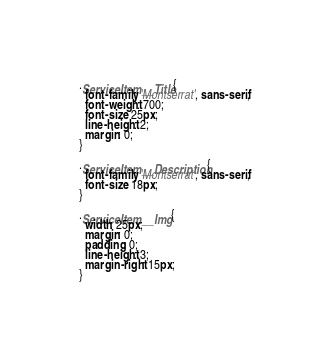Convert code to text. <code><loc_0><loc_0><loc_500><loc_500><_CSS_>.ServiceItem__Title {
  font-family: 'Montserrat', sans-serif;
  font-weight: 700;
  font-size: 25px;
  line-height: 2;
  margin: 0;
}

.ServiceItem__Description {
  font-family: 'Montserrat', sans-serif;
  font-size: 18px;
}

.ServiceItem__Img {
  width: 25px;
  margin: 0;
  padding: 0;
  line-height: 3;
  margin-right: 15px;
}
</code> 